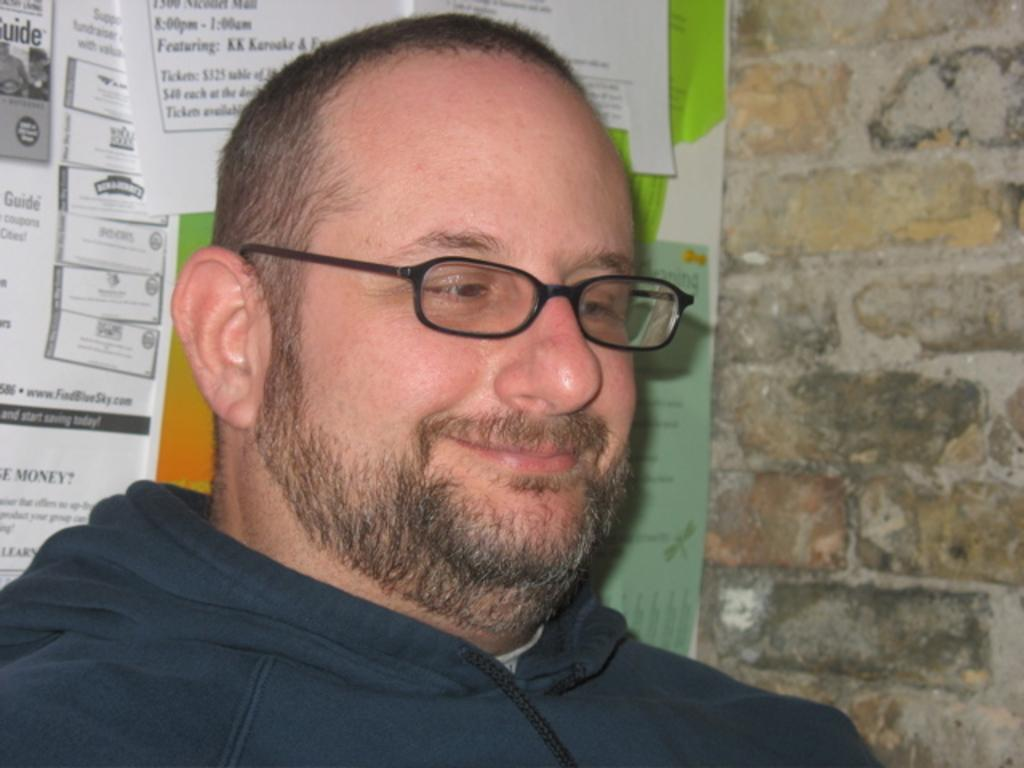Who or what is present in the image? There is a person in the image. What is the person doing or expressing? The person is smiling. What can be seen in the background of the image? There is a wall in the background of the image. What is on the wall in the image? There are posters on the wall. What type of zipper can be seen on the person's clothing in the image? There is no zipper visible on the person's clothing in the image. What time of day is it in the image? The time of day cannot be determined from the image, as there are no clues or indicators present. 